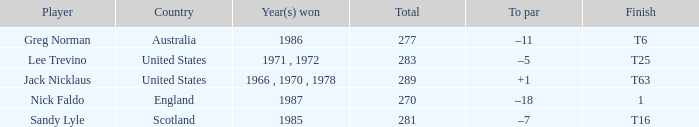What country has a total greater than 270, with sandy lyle as the player? Scotland. 